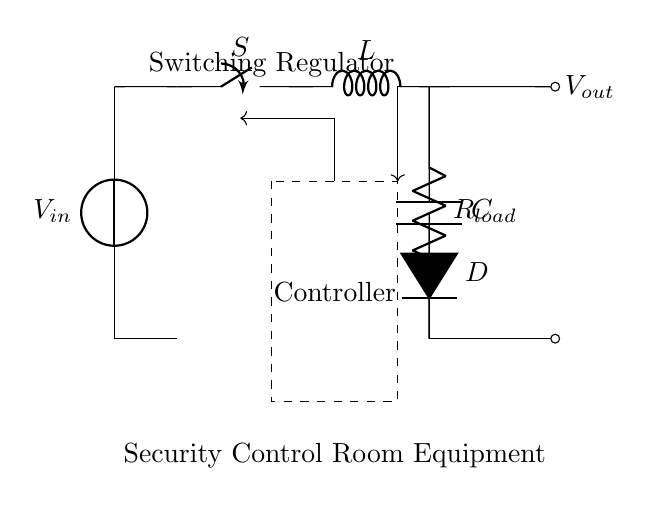What is the input voltage in this circuit? The input voltage is represented by the voltage source labeled V in the circuit, which is at the leftmost part of the diagram.
Answer: V What component is used to store energy in this circuit? The component that stores energy in the circuit is represented by the inductor labeled L, which is connected in the upper path toward the load and capacitor.
Answer: L What does the switch control in this circuit? The switch labeled S controls the flow of current through the inductor and determines the on/off state of the regulator operation to manage power delivery.
Answer: Current flow What is the purpose of the diode in this circuit? The diode labeled D allows current to flow in only one direction, preventing reverse current that might damage the circuit components and ensuring proper voltage delivery to the load.
Answer: Prevent reverse current How do you describe the function of the controller in this circuit? The controller, represented by a dashed rectangle, adjusts the duty cycle of the switch to maintain a stable output voltage regardless of input voltage fluctuations or load changes.
Answer: Regulates output voltage What is the output voltage connected to in this circuit? The output voltage labeled V out is connected to the load resistance component labeled R load, which consumes the regulated power supplied by the circuit.
Answer: R load What happens when the load resistance increases in this circuit? With an increase in load resistance, the current drawn from the output decreases, potentially leading to a higher output voltage if the controller adjusts the duty cycle accordingly to stabilize the output.
Answer: Output voltage increase 